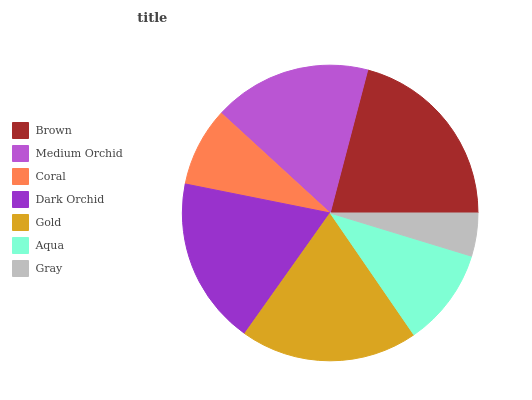Is Gray the minimum?
Answer yes or no. Yes. Is Brown the maximum?
Answer yes or no. Yes. Is Medium Orchid the minimum?
Answer yes or no. No. Is Medium Orchid the maximum?
Answer yes or no. No. Is Brown greater than Medium Orchid?
Answer yes or no. Yes. Is Medium Orchid less than Brown?
Answer yes or no. Yes. Is Medium Orchid greater than Brown?
Answer yes or no. No. Is Brown less than Medium Orchid?
Answer yes or no. No. Is Medium Orchid the high median?
Answer yes or no. Yes. Is Medium Orchid the low median?
Answer yes or no. Yes. Is Dark Orchid the high median?
Answer yes or no. No. Is Coral the low median?
Answer yes or no. No. 